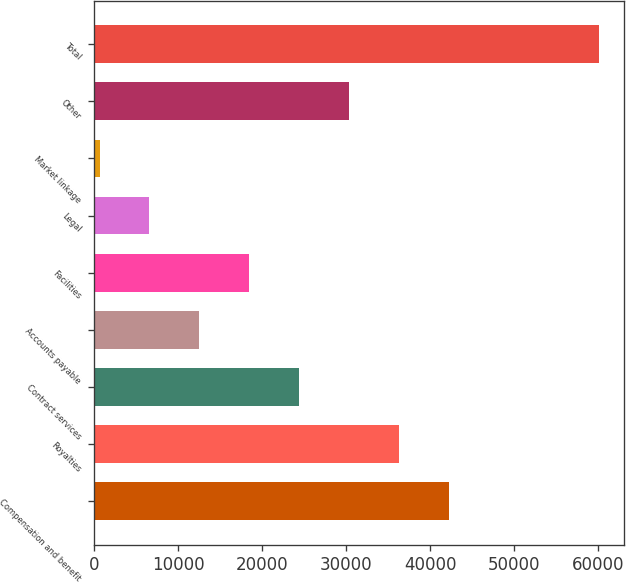Convert chart. <chart><loc_0><loc_0><loc_500><loc_500><bar_chart><fcel>Compensation and benefit<fcel>Royalties<fcel>Contract services<fcel>Accounts payable<fcel>Facilities<fcel>Legal<fcel>Market linkage<fcel>Other<fcel>Total<nl><fcel>42261.2<fcel>36313.6<fcel>24418.4<fcel>12523.2<fcel>18470.8<fcel>6575.6<fcel>628<fcel>30366<fcel>60104<nl></chart> 